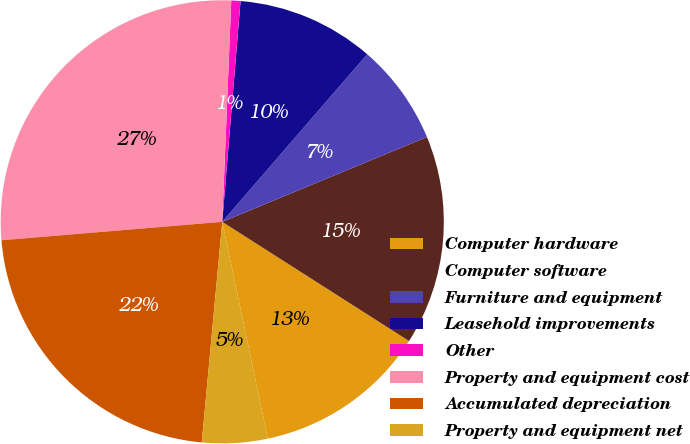Convert chart. <chart><loc_0><loc_0><loc_500><loc_500><pie_chart><fcel>Computer hardware<fcel>Computer software<fcel>Furniture and equipment<fcel>Leasehold improvements<fcel>Other<fcel>Property and equipment cost<fcel>Accumulated depreciation<fcel>Property and equipment net<nl><fcel>12.66%<fcel>15.29%<fcel>7.4%<fcel>10.03%<fcel>0.67%<fcel>26.97%<fcel>22.2%<fcel>4.77%<nl></chart> 